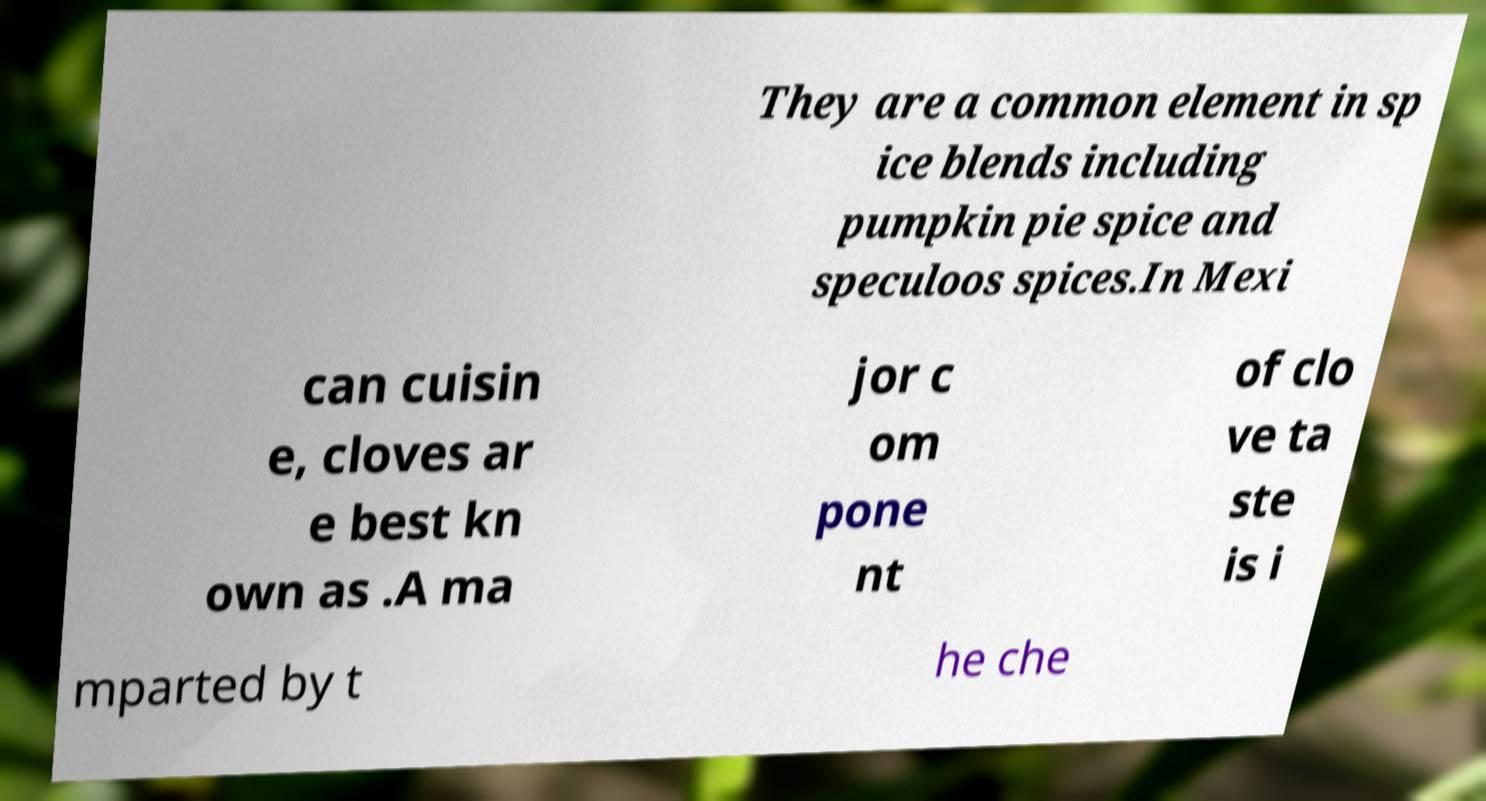I need the written content from this picture converted into text. Can you do that? They are a common element in sp ice blends including pumpkin pie spice and speculoos spices.In Mexi can cuisin e, cloves ar e best kn own as .A ma jor c om pone nt of clo ve ta ste is i mparted by t he che 